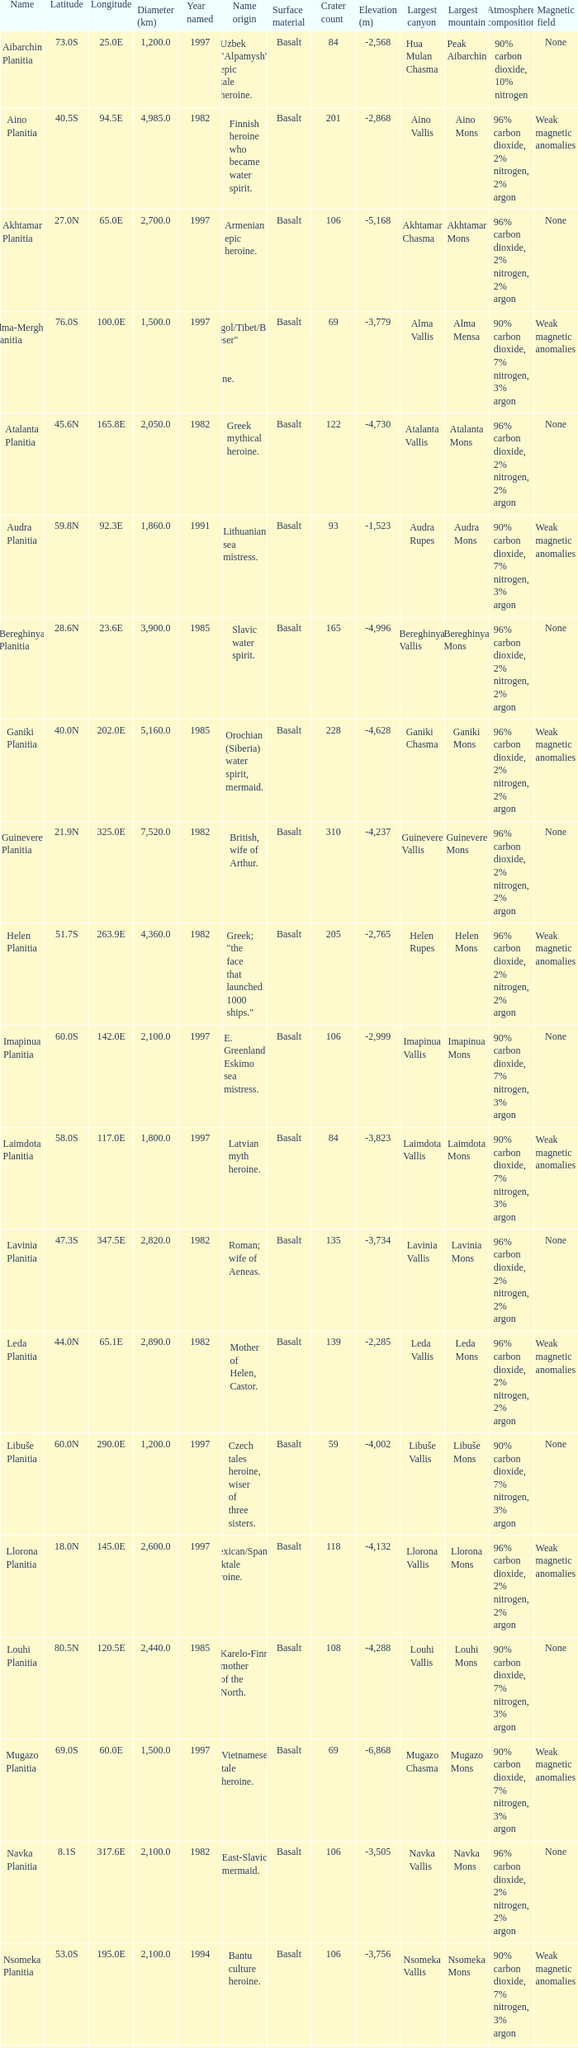What is the latitude of the feature of longitude 80.0e 23.0S. 